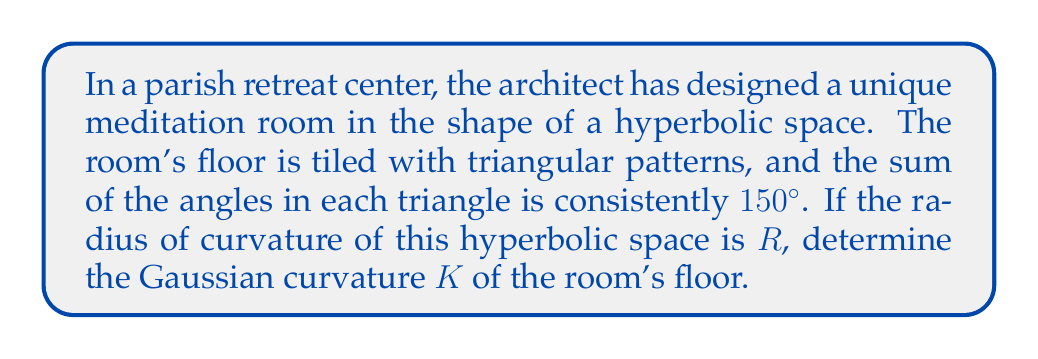Solve this math problem. To solve this problem, we'll follow these steps:

1) In hyperbolic geometry, the sum of the angles in a triangle is less than 180°. The difference between 180° and the actual sum is called the defect.

2) The defect (D) in this case is:
   $D = 180° - 150° = 30° = \frac{\pi}{6}$ radians

3) In hyperbolic geometry, the area (A) of a triangle is related to its defect by the formula:
   $A = \frac{D}{|K|}$

   Where K is the Gaussian curvature.

4) The Gaussian curvature of a hyperbolic space with radius of curvature R is given by:
   $K = -\frac{1}{R^2}$

5) Substituting this into the area formula:
   $A = \frac{D}{|-\frac{1}{R^2}|} = DR^2$

6) We don't know the actual area of the triangle, but we know that for any triangle in this space:
   $\frac{\pi}{6} = |-\frac{1}{R^2}|A$

7) Simplifying:
   $\frac{\pi}{6} = \frac{1}{R^2}A$

8) Therefore, the Gaussian curvature K is:
   $K = -\frac{1}{R^2} = -\frac{\pi}{6A}$

This final expression gives us the Gaussian curvature in terms of the area of a triangle with a defect of 30°.
Answer: The Gaussian curvature of the hyperbolic space is $K = -\frac{1}{R^2} = -\frac{\pi}{6A}$, where A is the area of a triangle with a defect of 30°. 